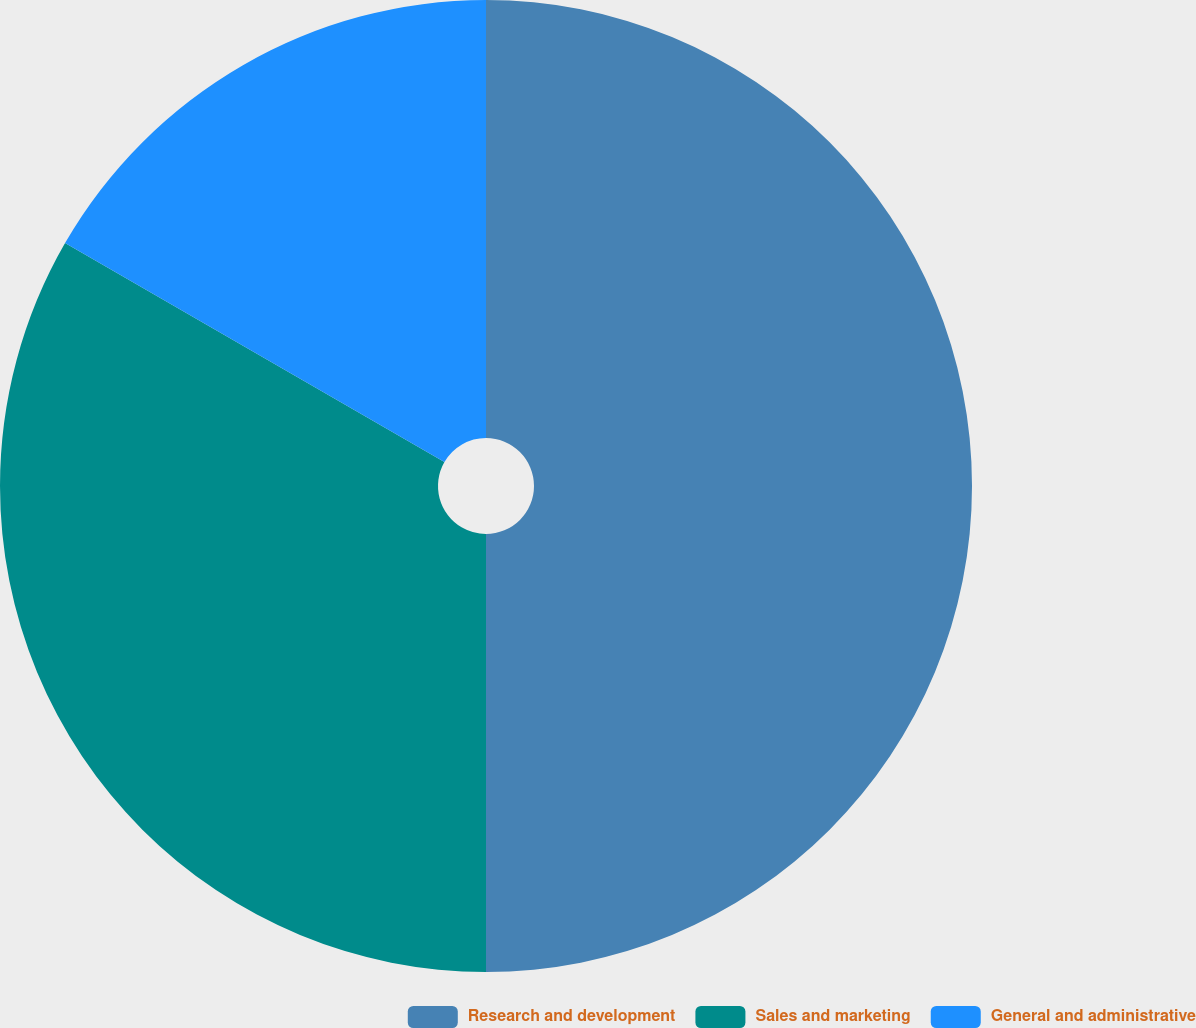<chart> <loc_0><loc_0><loc_500><loc_500><pie_chart><fcel>Research and development<fcel>Sales and marketing<fcel>General and administrative<nl><fcel>50.0%<fcel>33.33%<fcel>16.67%<nl></chart> 